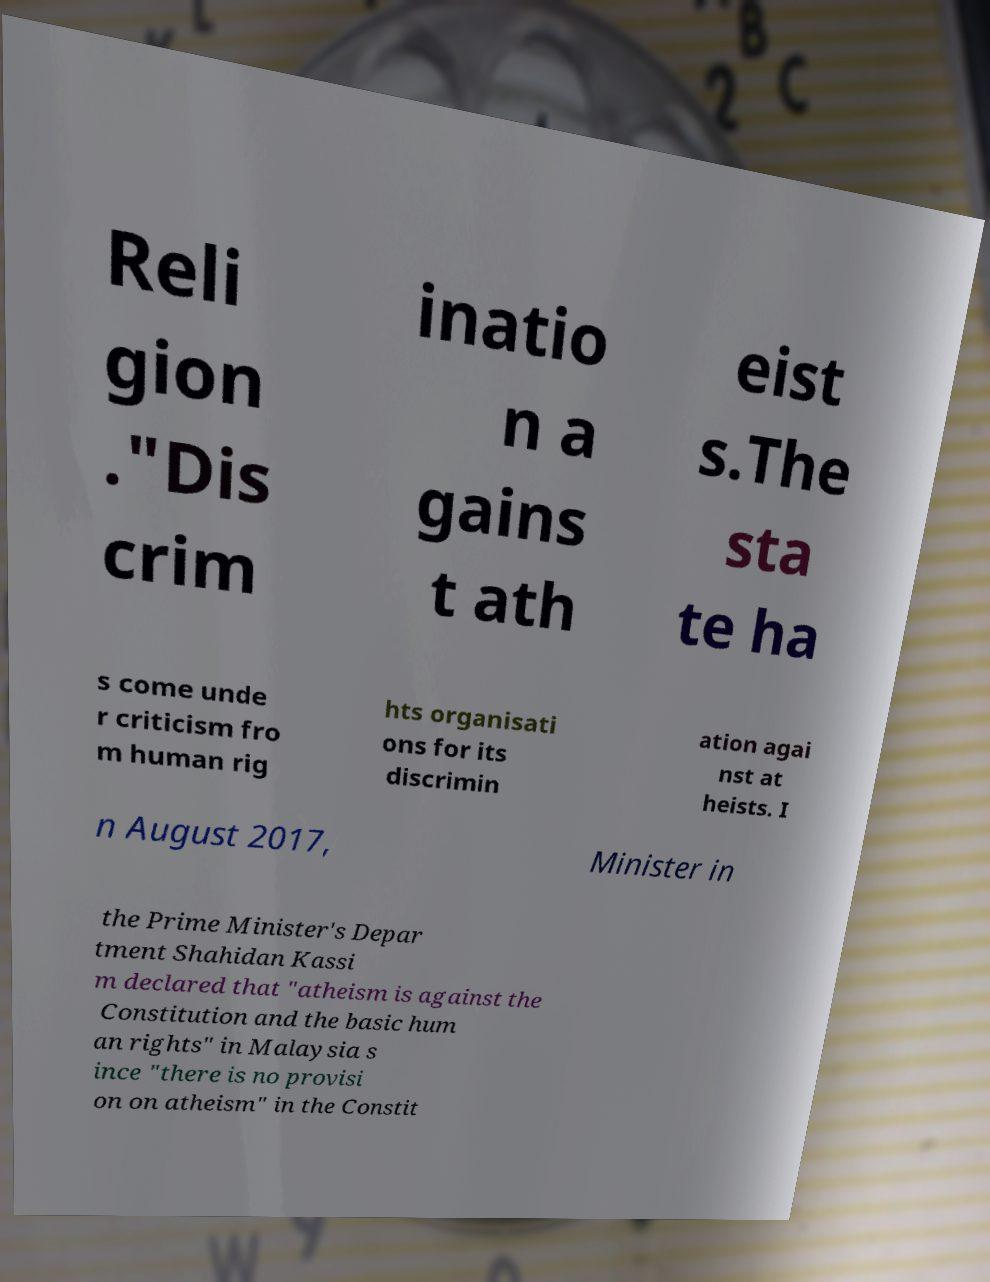There's text embedded in this image that I need extracted. Can you transcribe it verbatim? Reli gion ."Dis crim inatio n a gains t ath eist s.The sta te ha s come unde r criticism fro m human rig hts organisati ons for its discrimin ation agai nst at heists. I n August 2017, Minister in the Prime Minister's Depar tment Shahidan Kassi m declared that "atheism is against the Constitution and the basic hum an rights" in Malaysia s ince "there is no provisi on on atheism" in the Constit 